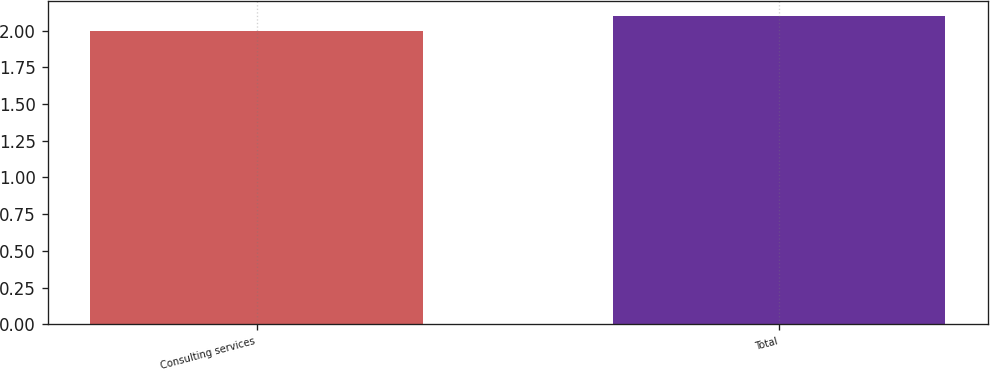<chart> <loc_0><loc_0><loc_500><loc_500><bar_chart><fcel>Consulting services<fcel>Total<nl><fcel>2<fcel>2.1<nl></chart> 